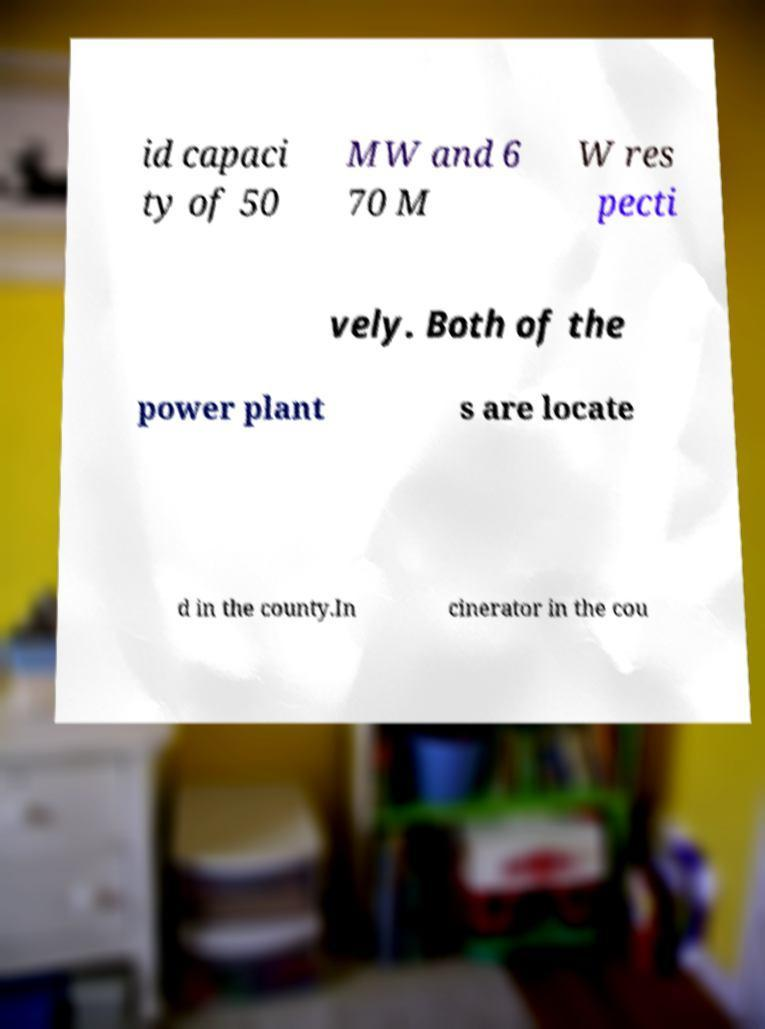I need the written content from this picture converted into text. Can you do that? id capaci ty of 50 MW and 6 70 M W res pecti vely. Both of the power plant s are locate d in the county.In cinerator in the cou 